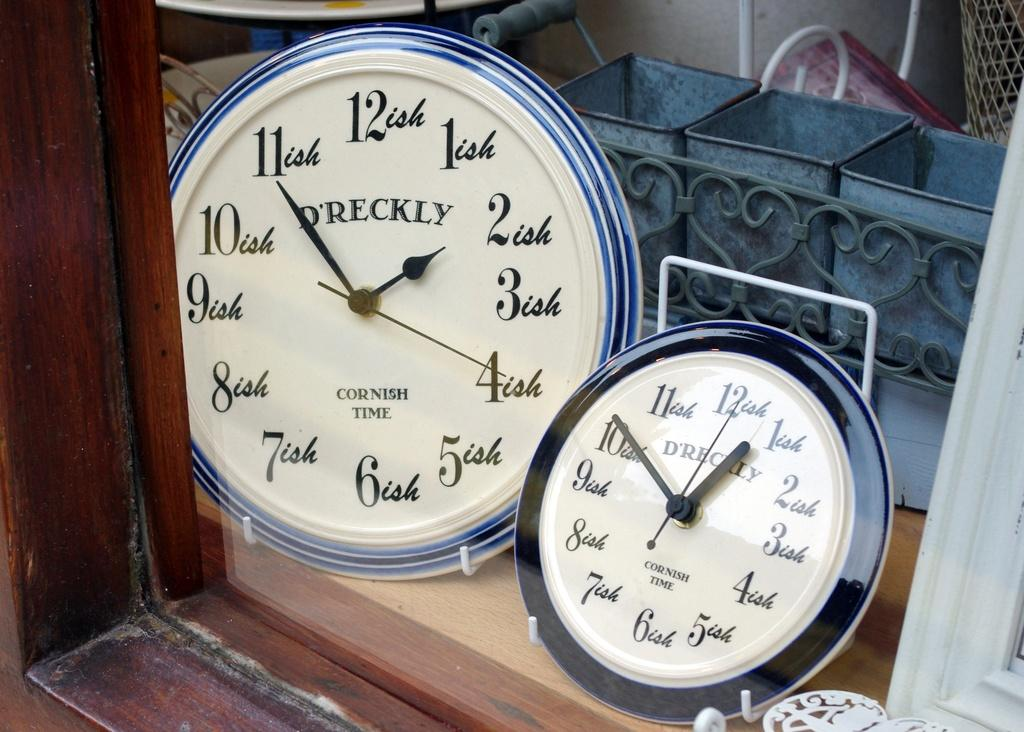Provide a one-sentence caption for the provided image. Two D'Reckly Wall Clocks display Cornish Time in a shop window. 